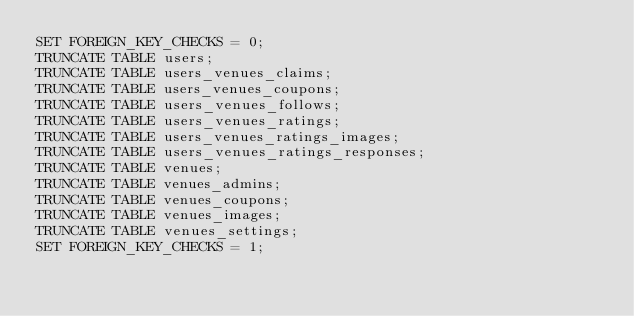Convert code to text. <code><loc_0><loc_0><loc_500><loc_500><_SQL_>SET FOREIGN_KEY_CHECKS = 0;
TRUNCATE TABLE users;
TRUNCATE TABLE users_venues_claims;
TRUNCATE TABLE users_venues_coupons;
TRUNCATE TABLE users_venues_follows;
TRUNCATE TABLE users_venues_ratings;
TRUNCATE TABLE users_venues_ratings_images;
TRUNCATE TABLE users_venues_ratings_responses;
TRUNCATE TABLE venues;
TRUNCATE TABLE venues_admins;
TRUNCATE TABLE venues_coupons;
TRUNCATE TABLE venues_images;
TRUNCATE TABLE venues_settings;
SET FOREIGN_KEY_CHECKS = 1;</code> 